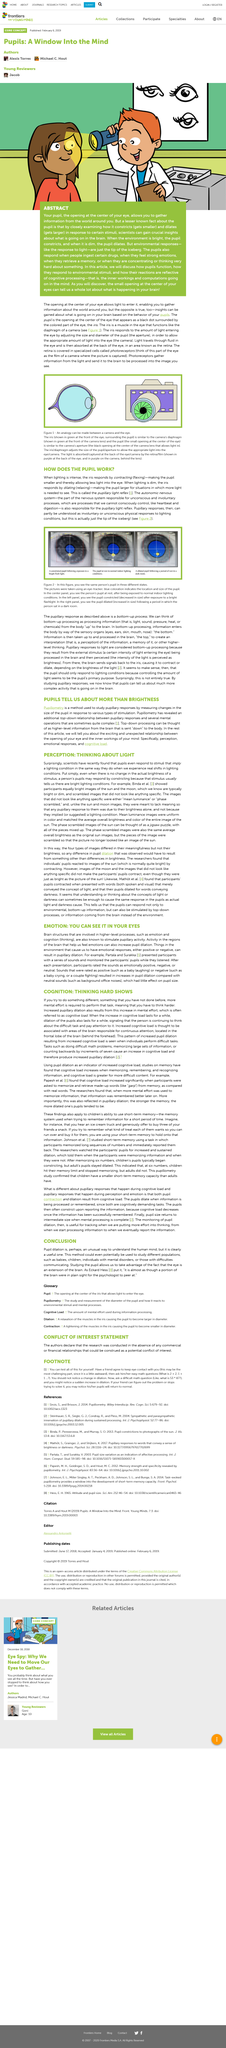Outline some significant characteristics in this image. Yes, insights are gained based on what is happening in your brain based on the behavior of your pupils. The researchers' findings revealed that individuals' pupils reacted to images of the sun. The opening at the center of your eye, known as the pupil, enables you to gather information about the world around you. The process of the iris contracting and dilating to change the size of the pupil to control the amount of light getting into the eye is called the pupillary light reflex. The autonomic nervous system is responsible for the pupillary light reflex. 